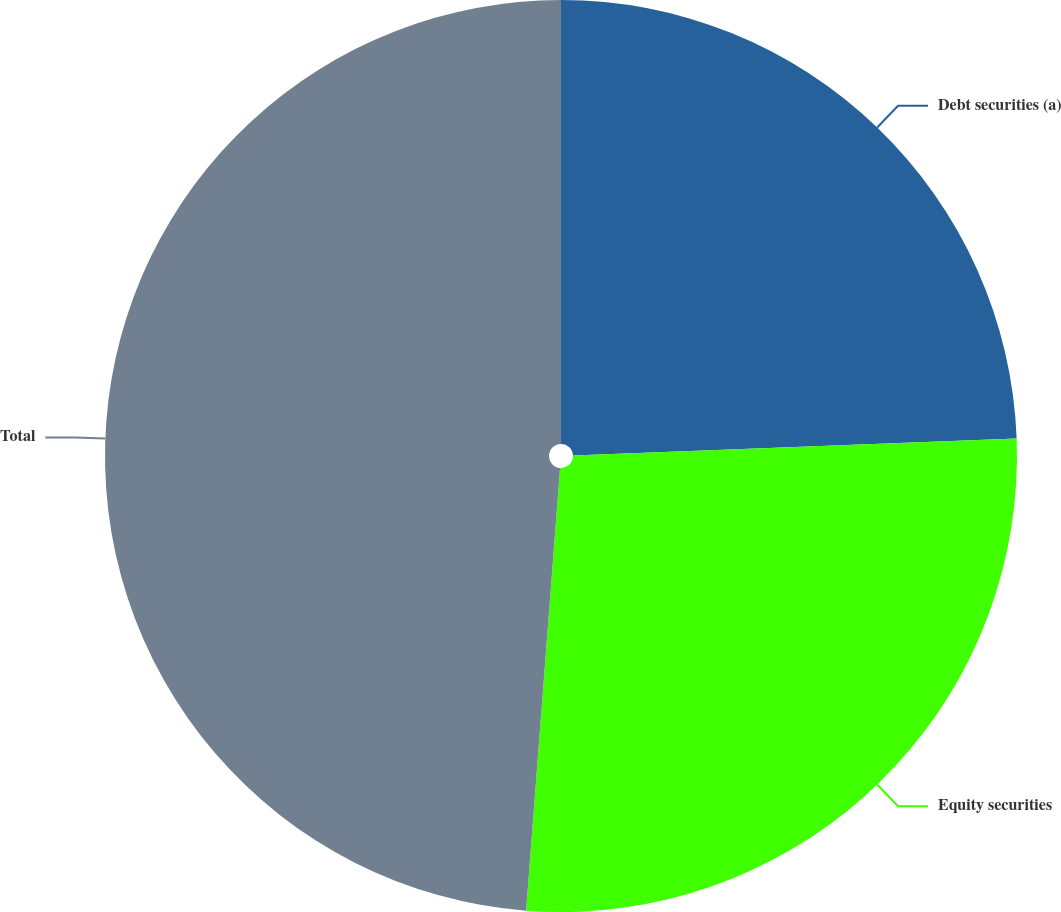Convert chart to OTSL. <chart><loc_0><loc_0><loc_500><loc_500><pie_chart><fcel>Debt securities (a)<fcel>Equity securities<fcel>Total<nl><fcel>24.39%<fcel>26.83%<fcel>48.78%<nl></chart> 